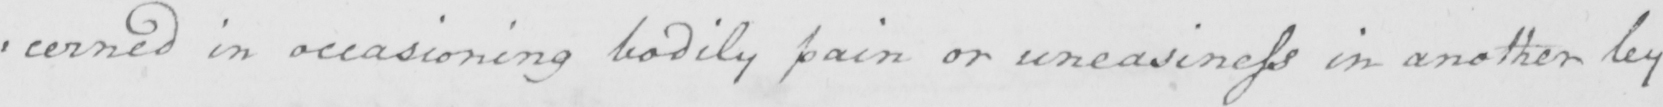What does this handwritten line say? : cerned in occasioning bodily pain or uneasiness in another by 